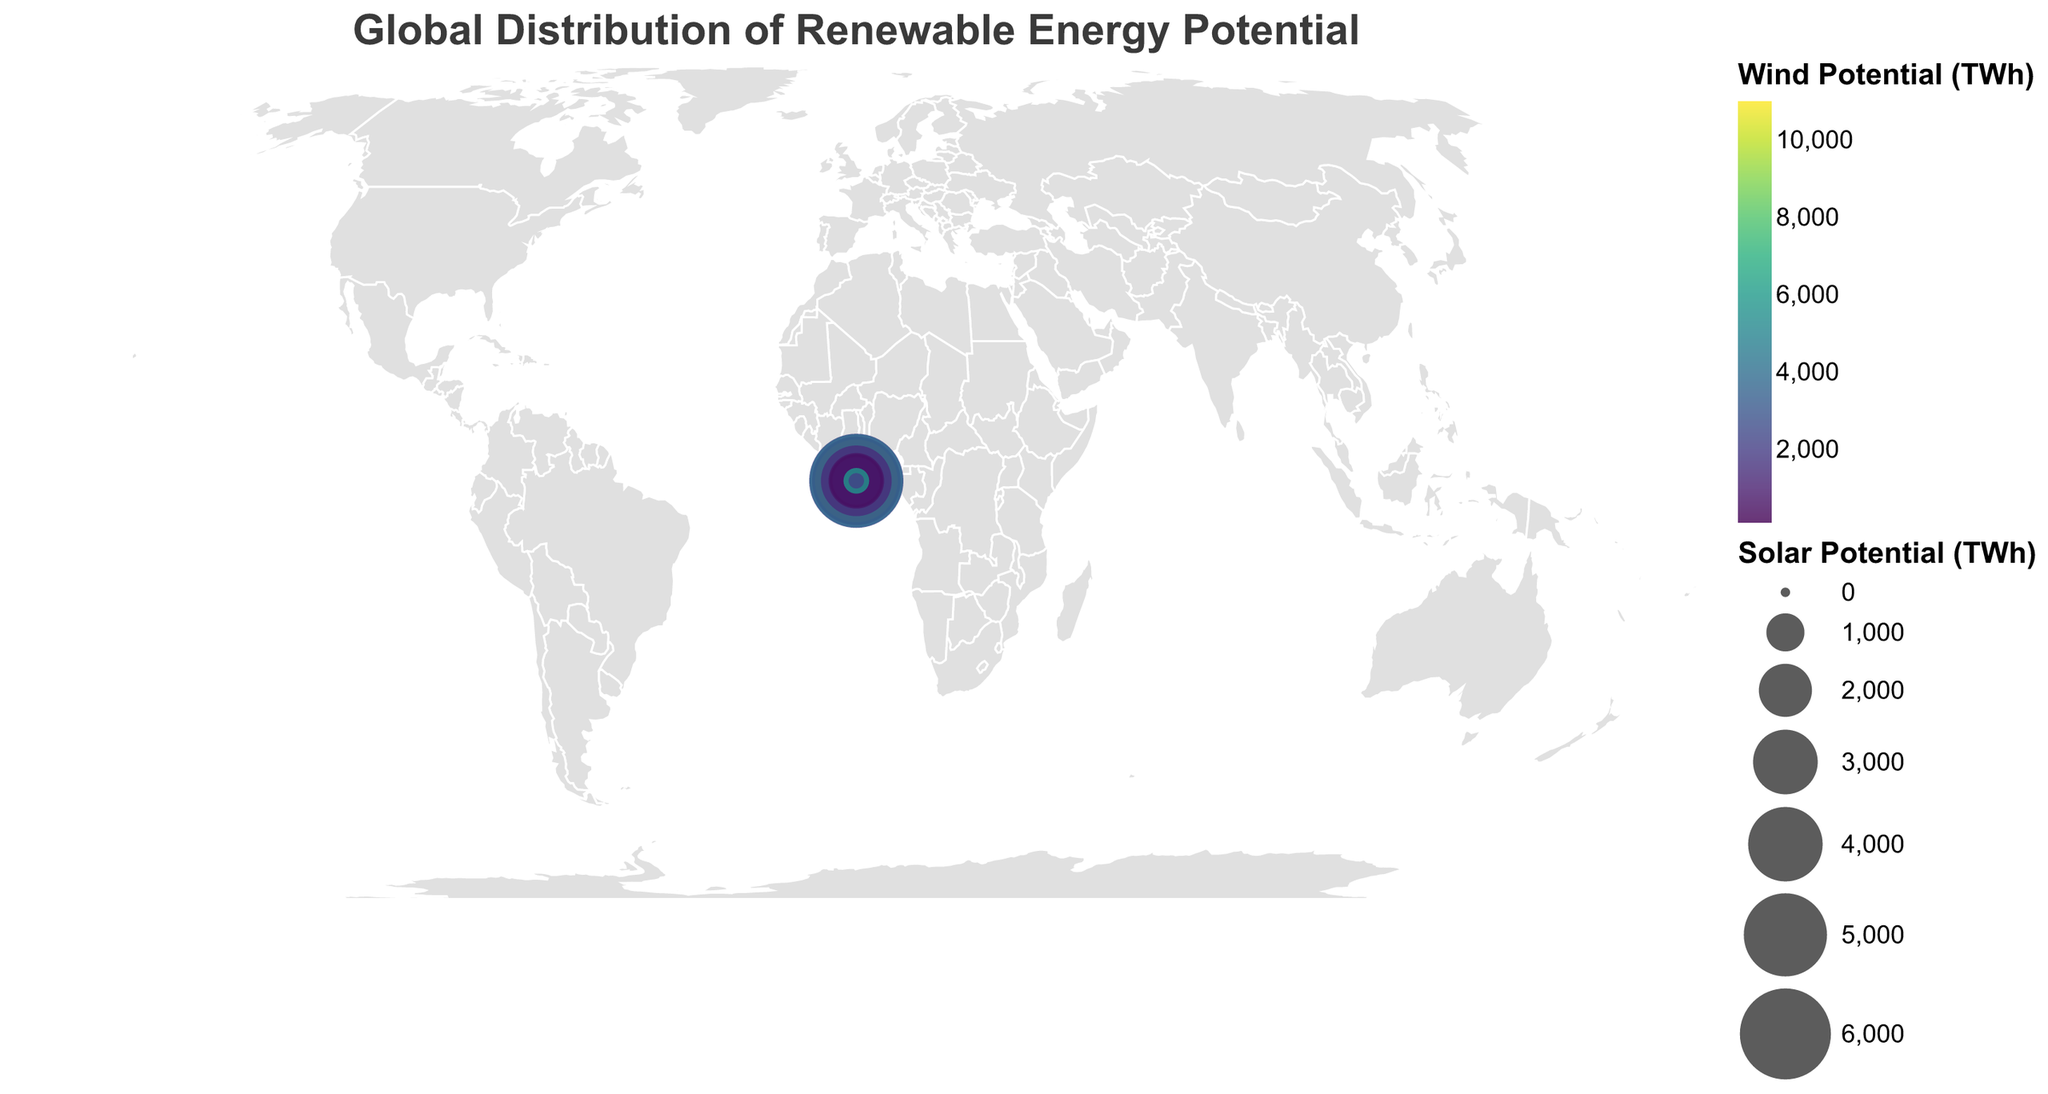What's the country with the highest solar potential? The size of the circles represents the solar potential. The largest circle is located in Australia.
Answer: Australia Which country has the largest wind potential? The color intensity represents the wind potential. The United States shows the most intense color, indicating the highest wind potential.
Answer: United States What's the relationship between the size of circles and renewable share percentage? By examining the circles and the renewable share percentages in the tooltip, it's observed that larger circles do not necessarily correlate with higher renewable share percentages.
Answer: No direct correlation For Germany, is the wind potential higher than the solar potential? Germany's tooltip shows a wind potential of 1870 TWh and a solar potential of 141 TWh. 1870 is greater than 141.
Answer: Yes Which country has the highest renewable share percentage, and what's that value? The tooltip for Kenya shows the highest renewable share percentage at 73.1%.
Answer: Kenya, 73.1% Which countries have a renewable share percentage above 50%? The tooltips show that Kenya and Canada have renewable share percentages above 50%, specifically 73.1% and 66.5% respectively.
Answer: Kenya and Canada How does the renewable share percentage of Brazil compare to the United States? From the tooltips, Brazil has a renewable share of 45.0%, while the United States has 17.5%. 45.0 is greater than 17.5.
Answer: Brazil has a higher percentage What is the combined solar potential of India and Morocco? The solar potentials of India and Morocco are 5650 TWh and 1780 TWh respectively. Adding these gives 5650 + 1780 = 7430 TWh.
Answer: 7430 TWh Are there any countries with wind potential above 5000 TWh? From the tooltips, the only countries with wind potential above 5000 TWh are the United States with 11000 TWh and Canada with 5820 TWh.
Answer: United States and Canada What's the highest wind potential observed, and which country does it belong to? The tooltip for the United States shows a wind potential of 11000 TWh, which is the highest in the dataset.
Answer: United States with 11000 TWh 